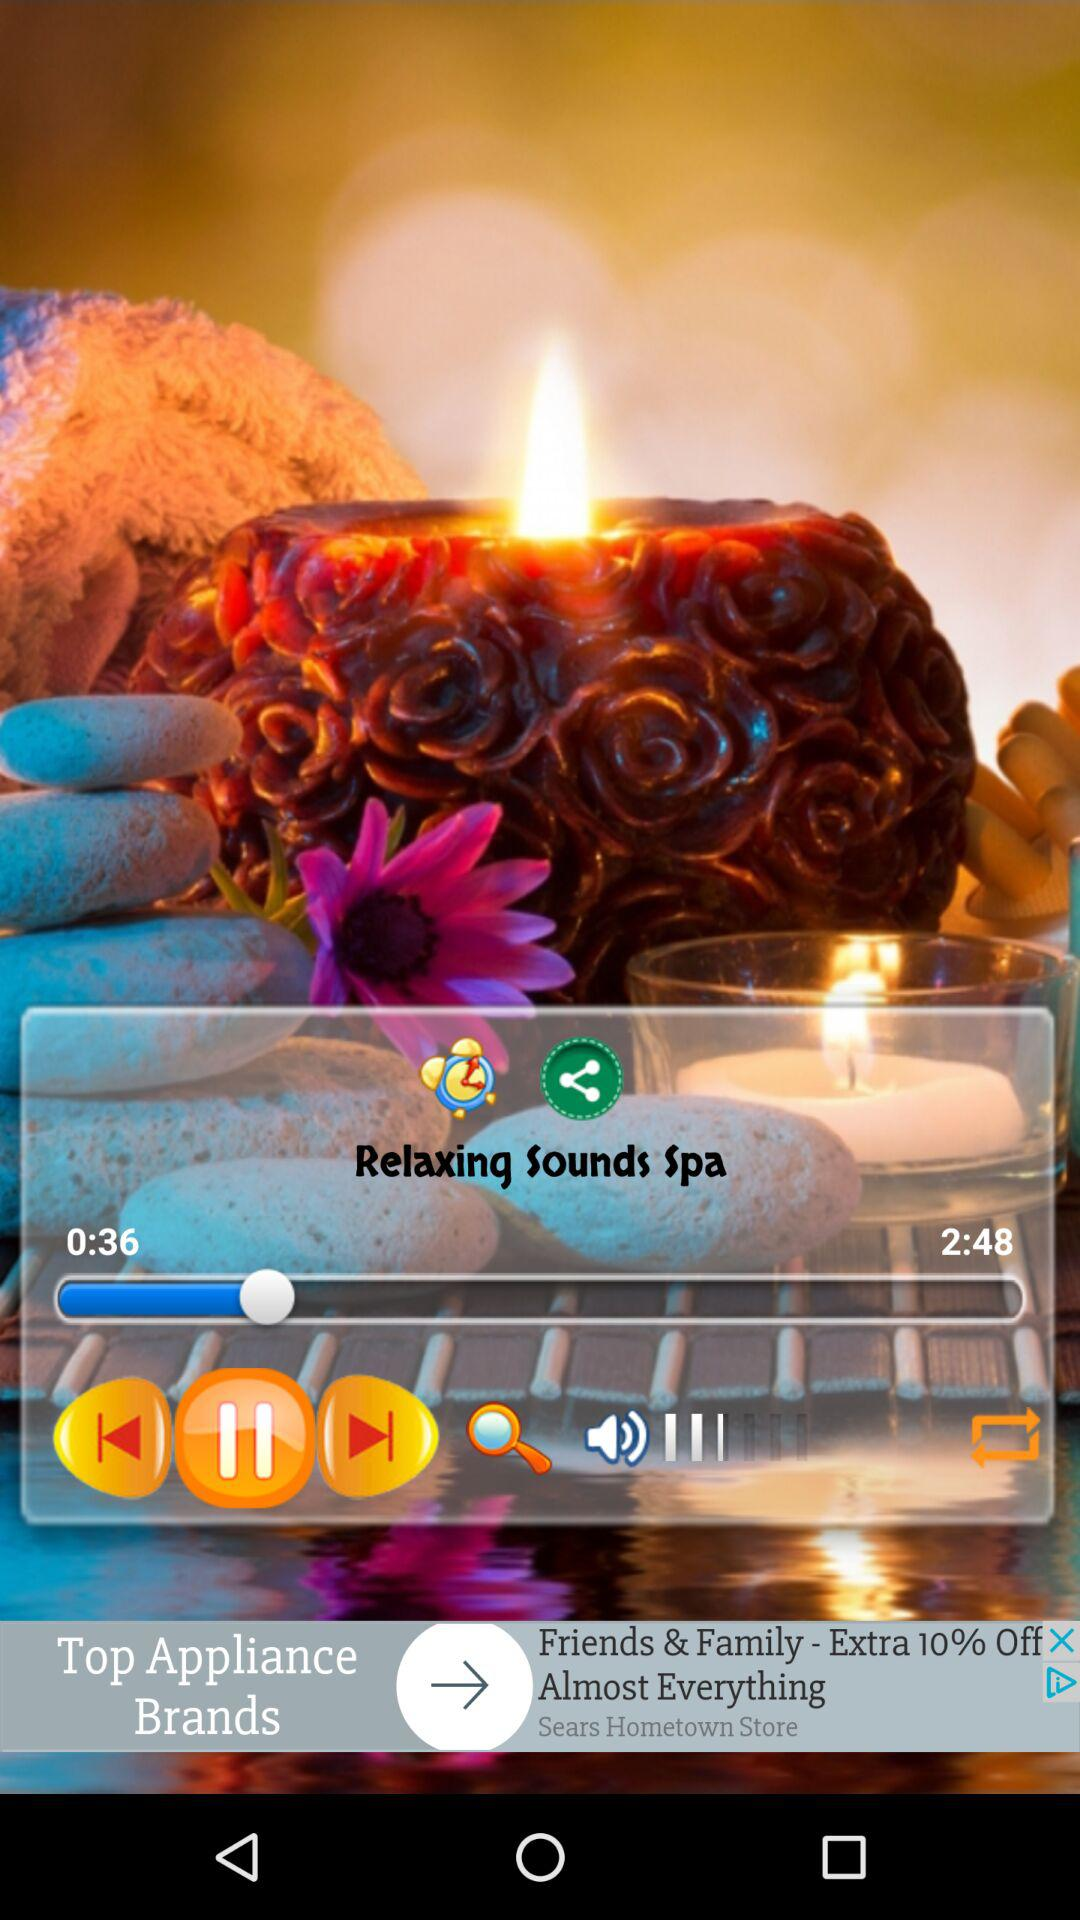Through which applications can this be shared?
When the provided information is insufficient, respond with <no answer>. <no answer> 